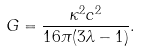Convert formula to latex. <formula><loc_0><loc_0><loc_500><loc_500>G = \frac { \kappa ^ { 2 } c ^ { 2 } } { 1 6 \pi ( 3 \lambda - 1 ) } .</formula> 